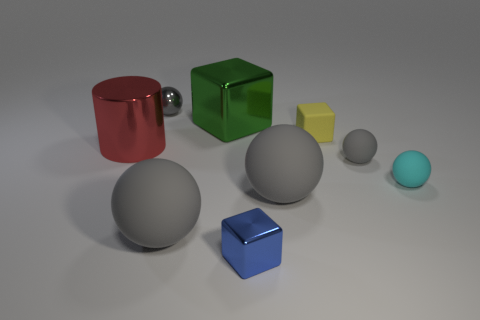Subtract all red cubes. How many gray spheres are left? 4 Subtract all small cyan balls. How many balls are left? 4 Subtract all cyan balls. How many balls are left? 4 Subtract all brown spheres. Subtract all purple blocks. How many spheres are left? 5 Add 1 red metallic things. How many objects exist? 10 Subtract all balls. How many objects are left? 4 Subtract 0 purple balls. How many objects are left? 9 Subtract all large green blocks. Subtract all red cylinders. How many objects are left? 7 Add 3 green cubes. How many green cubes are left? 4 Add 6 tiny yellow matte balls. How many tiny yellow matte balls exist? 6 